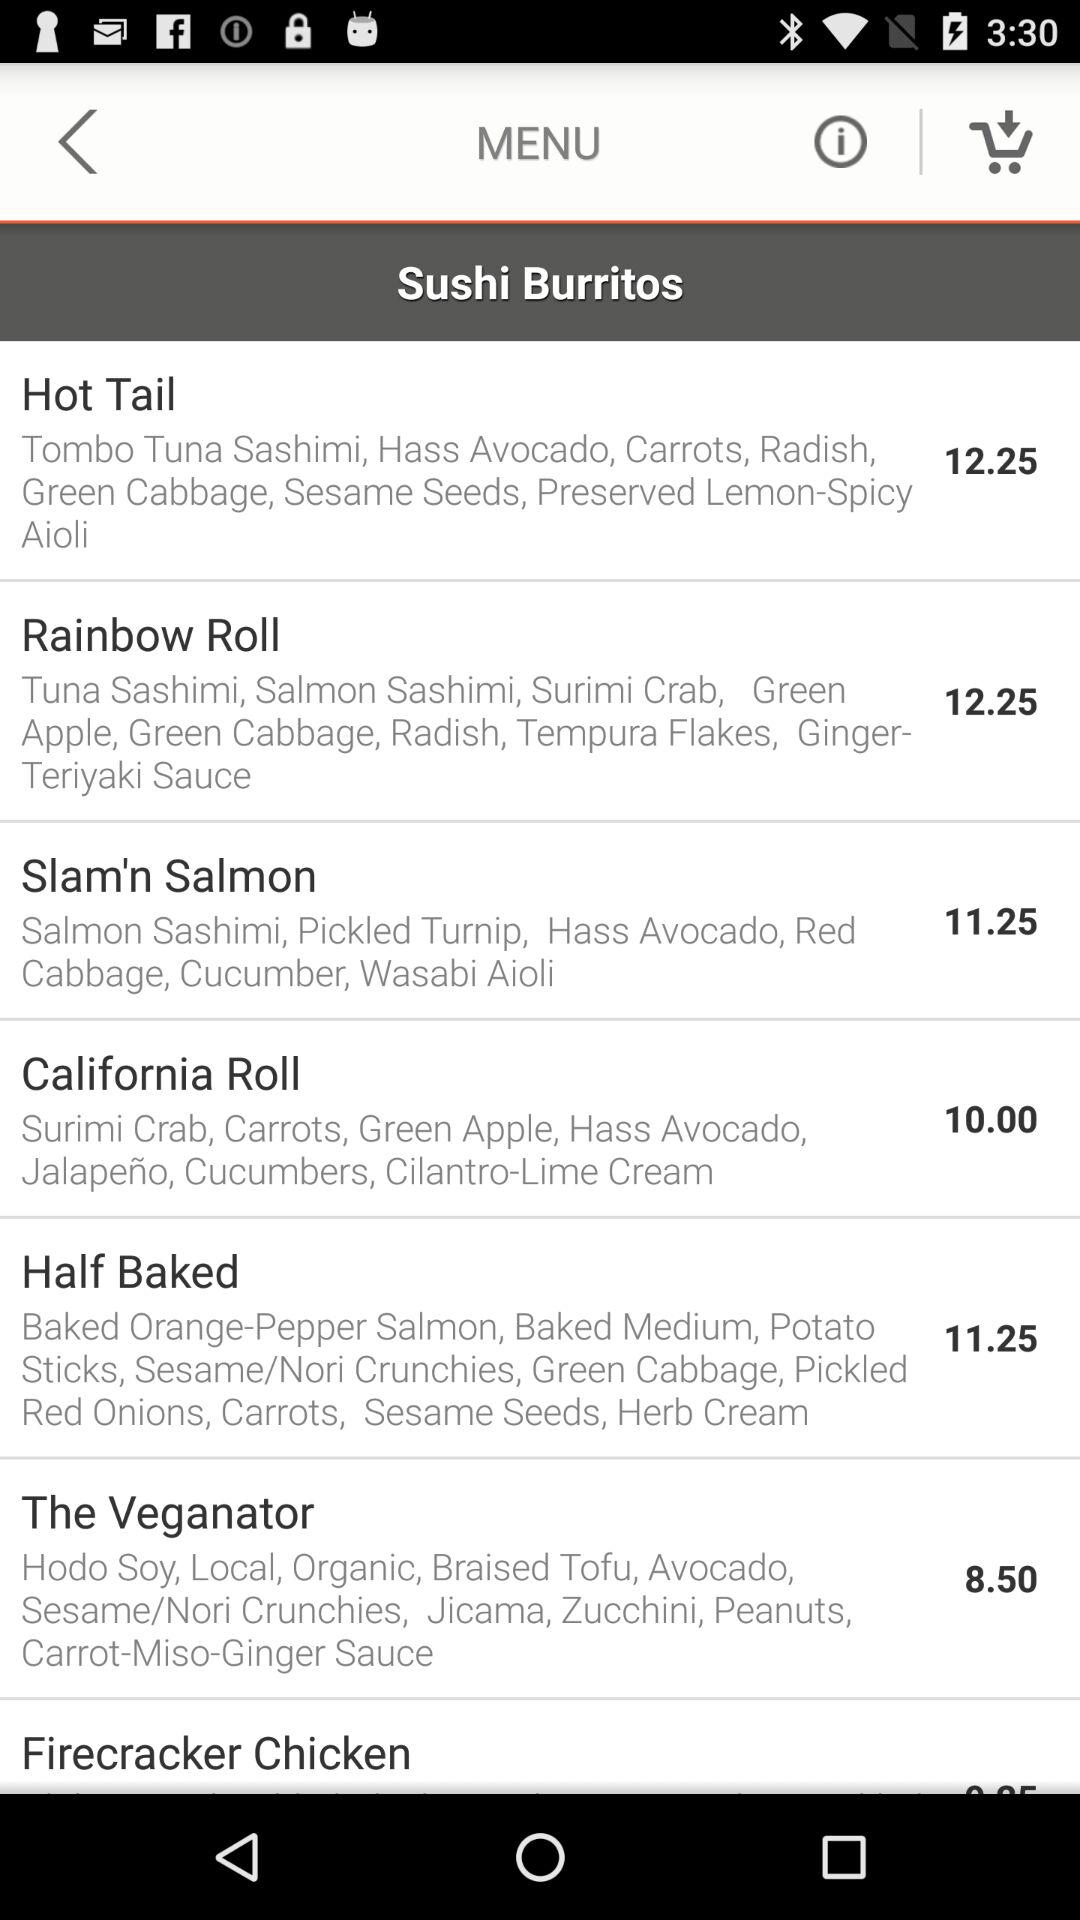What is the price shown for "The Veganator"? The price shown for "The Veganator" is 8.50. 